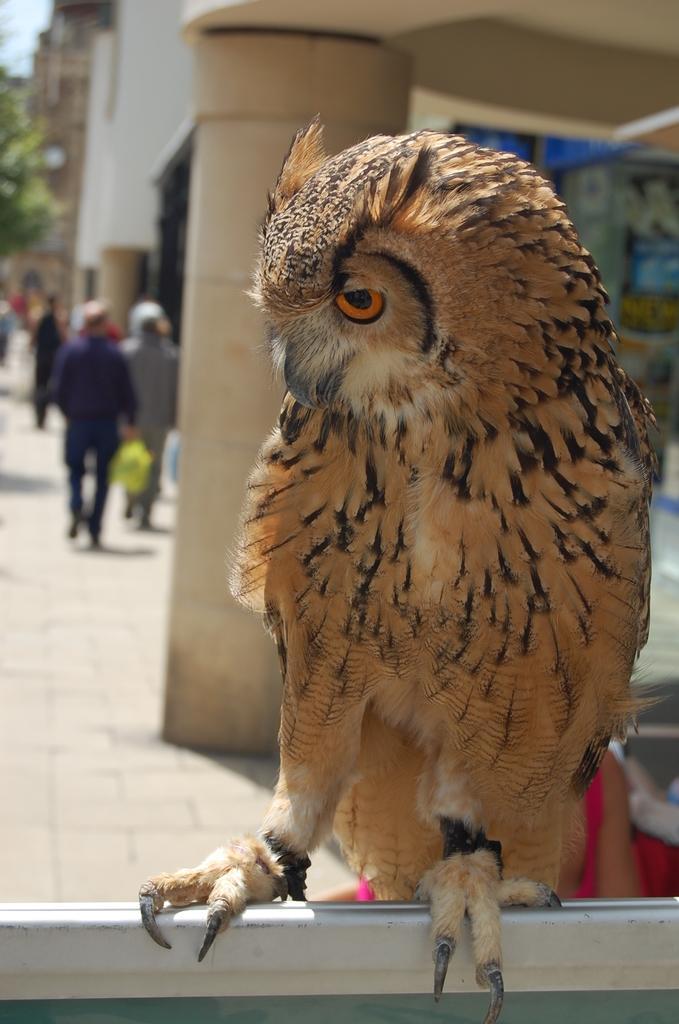Could you give a brief overview of what you see in this image? In this picture we can see a owl on the metal rod, in the background we can see few people are walking on the pathway, and also we can see few buildings and trees. 